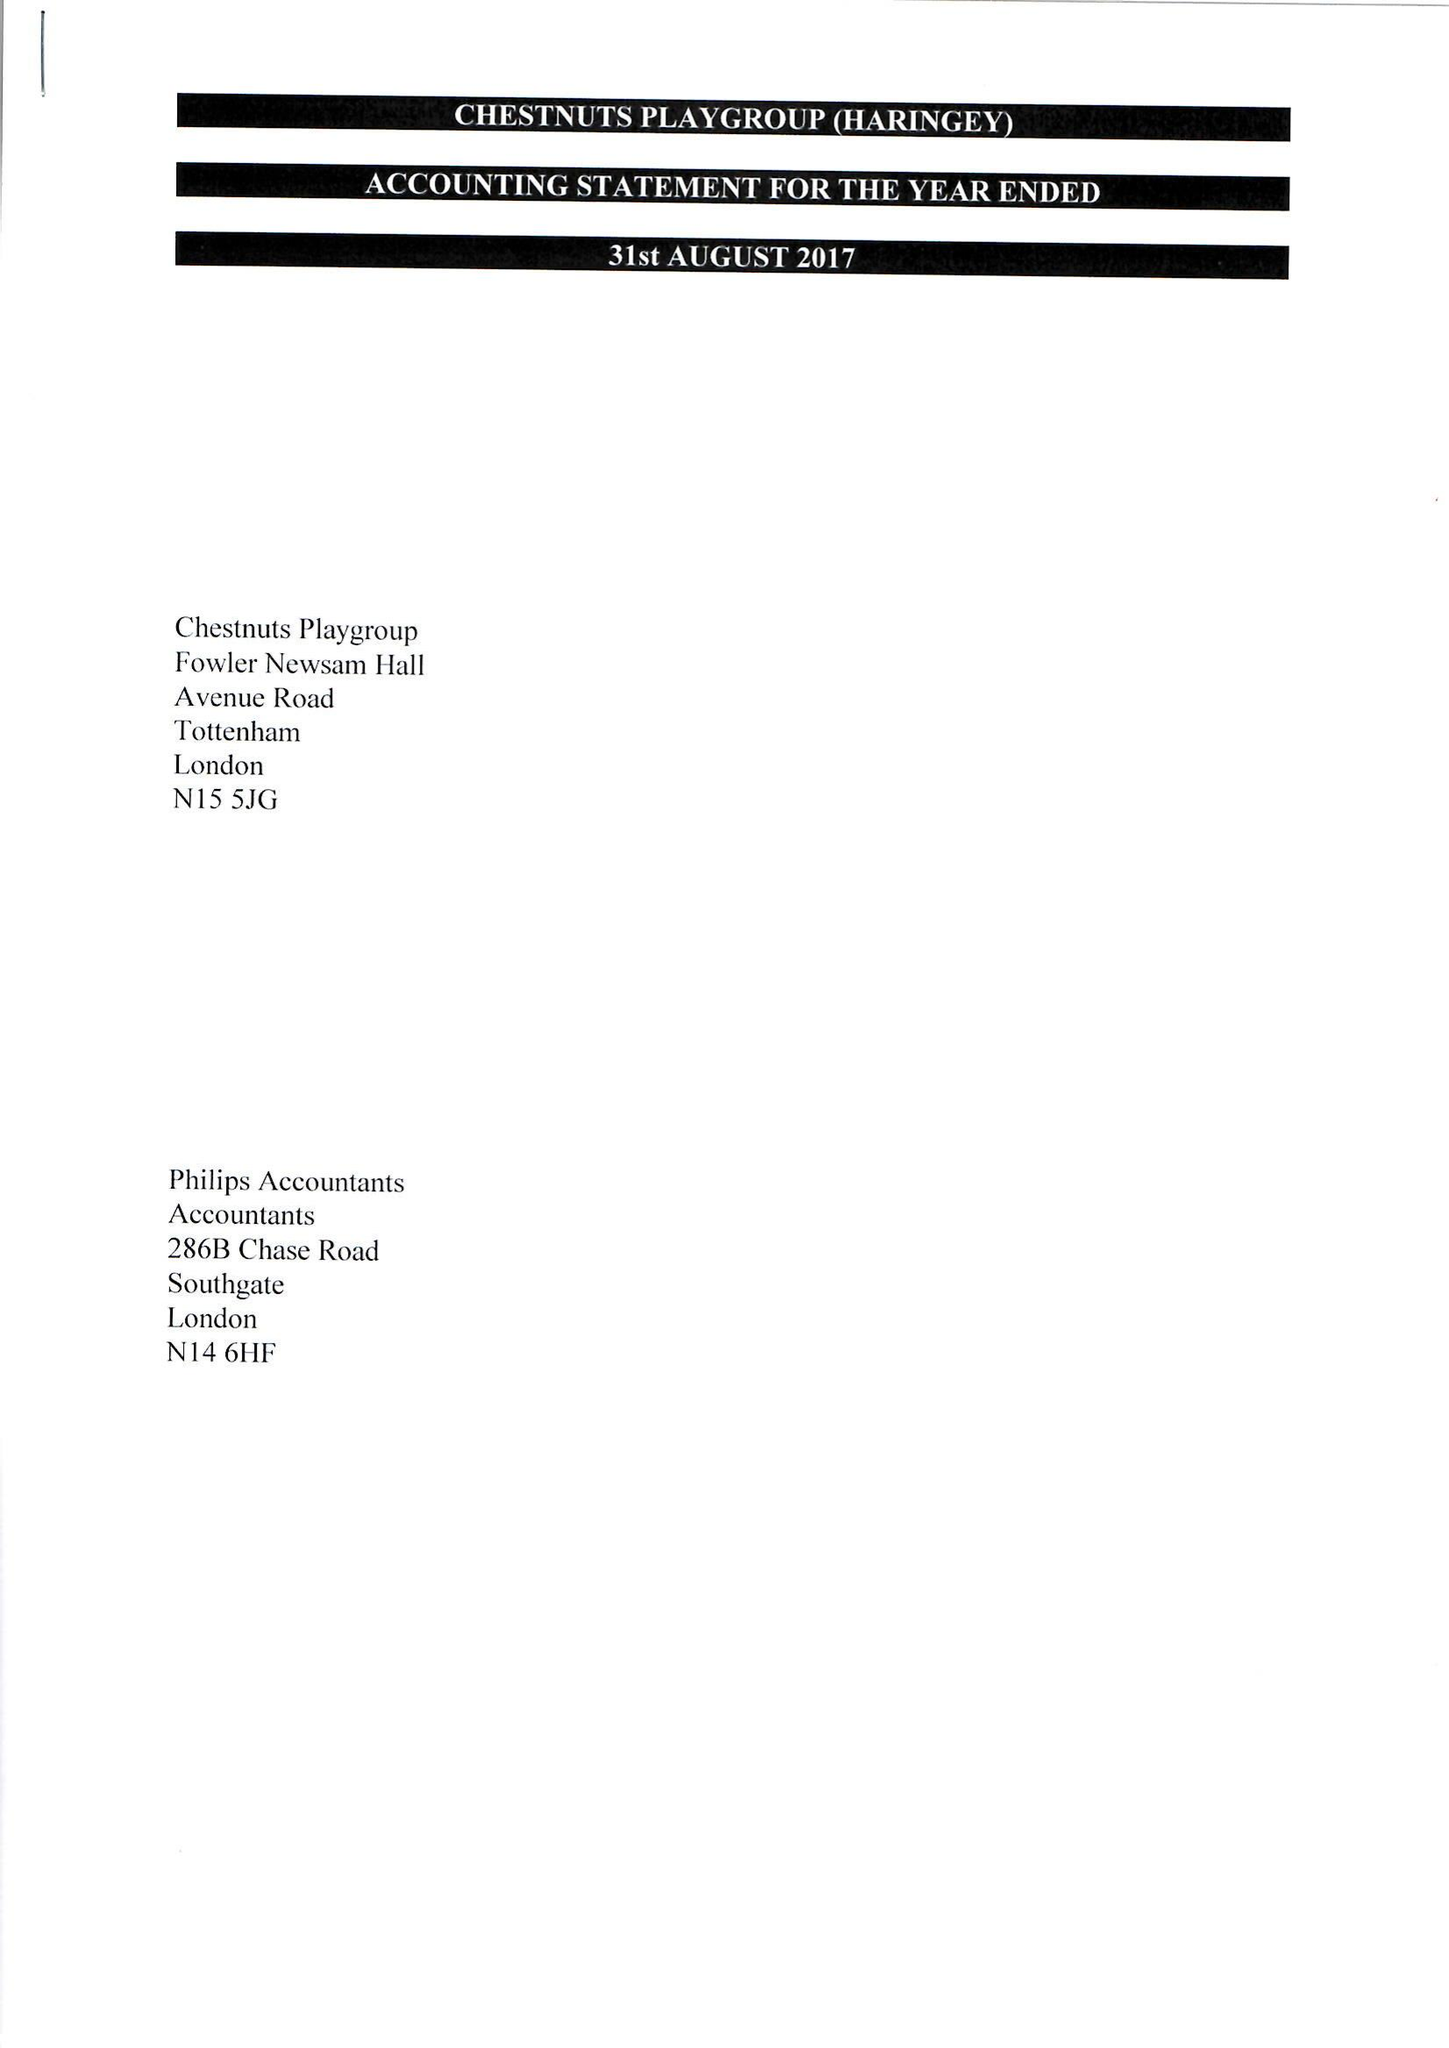What is the value for the address__street_line?
Answer the question using a single word or phrase. AVENUE ROAD 